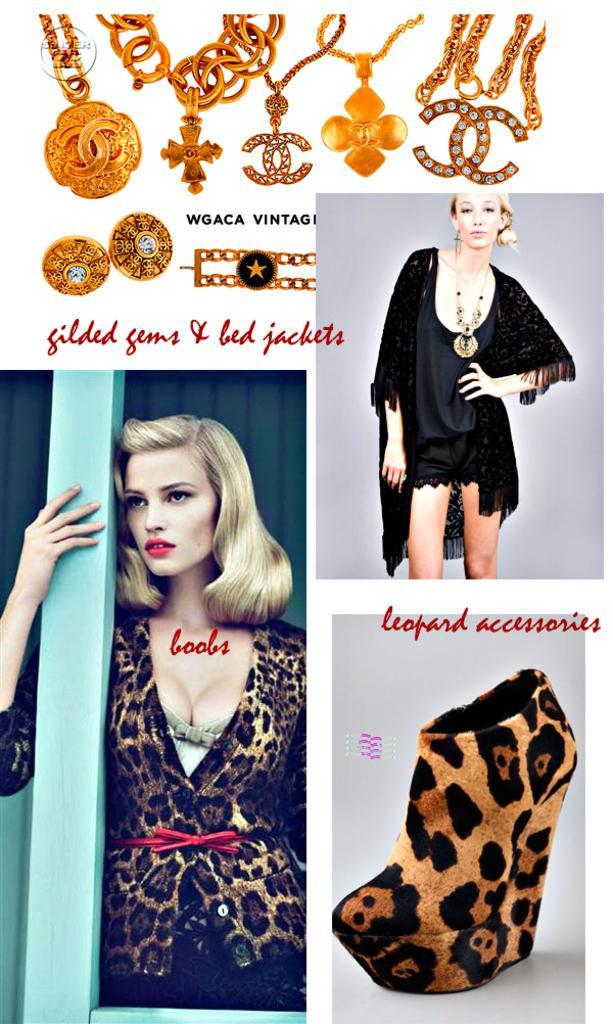Please provide a concise description of this image. This is the picture of a collage photo which consist of some photos and at the top of the image we can see some accessories and there is some text on it. We can see a woman standing and posing for photo on the left side and there is a photo of a woman wearing a black dress on the right side and we can see a shoe. 